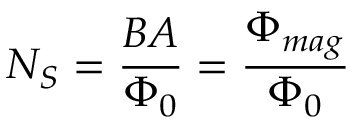Convert formula to latex. <formula><loc_0><loc_0><loc_500><loc_500>N _ { S } = { \frac { B A } { \Phi _ { 0 } } } = { \frac { \Phi _ { m a g } } { \Phi _ { 0 } } }</formula> 